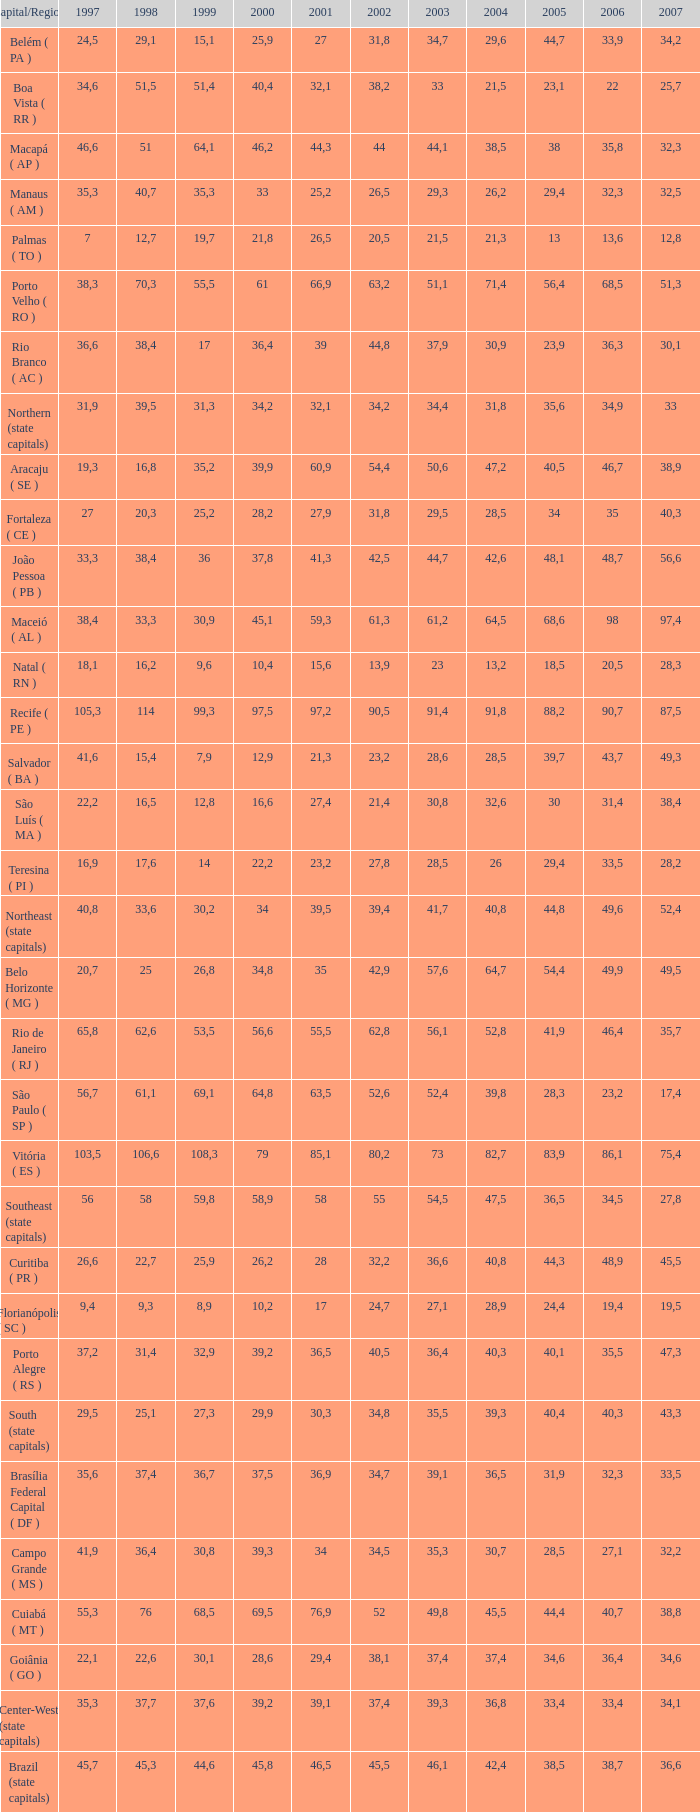Could you parse the entire table as a dict? {'header': ['Capital/Region', '1997', '1998', '1999', '2000', '2001', '2002', '2003', '2004', '2005', '2006', '2007'], 'rows': [['Belém ( PA )', '24,5', '29,1', '15,1', '25,9', '27', '31,8', '34,7', '29,6', '44,7', '33,9', '34,2'], ['Boa Vista ( RR )', '34,6', '51,5', '51,4', '40,4', '32,1', '38,2', '33', '21,5', '23,1', '22', '25,7'], ['Macapá ( AP )', '46,6', '51', '64,1', '46,2', '44,3', '44', '44,1', '38,5', '38', '35,8', '32,3'], ['Manaus ( AM )', '35,3', '40,7', '35,3', '33', '25,2', '26,5', '29,3', '26,2', '29,4', '32,3', '32,5'], ['Palmas ( TO )', '7', '12,7', '19,7', '21,8', '26,5', '20,5', '21,5', '21,3', '13', '13,6', '12,8'], ['Porto Velho ( RO )', '38,3', '70,3', '55,5', '61', '66,9', '63,2', '51,1', '71,4', '56,4', '68,5', '51,3'], ['Rio Branco ( AC )', '36,6', '38,4', '17', '36,4', '39', '44,8', '37,9', '30,9', '23,9', '36,3', '30,1'], ['Northern (state capitals)', '31,9', '39,5', '31,3', '34,2', '32,1', '34,2', '34,4', '31,8', '35,6', '34,9', '33'], ['Aracaju ( SE )', '19,3', '16,8', '35,2', '39,9', '60,9', '54,4', '50,6', '47,2', '40,5', '46,7', '38,9'], ['Fortaleza ( CE )', '27', '20,3', '25,2', '28,2', '27,9', '31,8', '29,5', '28,5', '34', '35', '40,3'], ['João Pessoa ( PB )', '33,3', '38,4', '36', '37,8', '41,3', '42,5', '44,7', '42,6', '48,1', '48,7', '56,6'], ['Maceió ( AL )', '38,4', '33,3', '30,9', '45,1', '59,3', '61,3', '61,2', '64,5', '68,6', '98', '97,4'], ['Natal ( RN )', '18,1', '16,2', '9,6', '10,4', '15,6', '13,9', '23', '13,2', '18,5', '20,5', '28,3'], ['Recife ( PE )', '105,3', '114', '99,3', '97,5', '97,2', '90,5', '91,4', '91,8', '88,2', '90,7', '87,5'], ['Salvador ( BA )', '41,6', '15,4', '7,9', '12,9', '21,3', '23,2', '28,6', '28,5', '39,7', '43,7', '49,3'], ['São Luís ( MA )', '22,2', '16,5', '12,8', '16,6', '27,4', '21,4', '30,8', '32,6', '30', '31,4', '38,4'], ['Teresina ( PI )', '16,9', '17,6', '14', '22,2', '23,2', '27,8', '28,5', '26', '29,4', '33,5', '28,2'], ['Northeast (state capitals)', '40,8', '33,6', '30,2', '34', '39,5', '39,4', '41,7', '40,8', '44,8', '49,6', '52,4'], ['Belo Horizonte ( MG )', '20,7', '25', '26,8', '34,8', '35', '42,9', '57,6', '64,7', '54,4', '49,9', '49,5'], ['Rio de Janeiro ( RJ )', '65,8', '62,6', '53,5', '56,6', '55,5', '62,8', '56,1', '52,8', '41,9', '46,4', '35,7'], ['São Paulo ( SP )', '56,7', '61,1', '69,1', '64,8', '63,5', '52,6', '52,4', '39,8', '28,3', '23,2', '17,4'], ['Vitória ( ES )', '103,5', '106,6', '108,3', '79', '85,1', '80,2', '73', '82,7', '83,9', '86,1', '75,4'], ['Southeast (state capitals)', '56', '58', '59,8', '58,9', '58', '55', '54,5', '47,5', '36,5', '34,5', '27,8'], ['Curitiba ( PR )', '26,6', '22,7', '25,9', '26,2', '28', '32,2', '36,6', '40,8', '44,3', '48,9', '45,5'], ['Florianópolis ( SC )', '9,4', '9,3', '8,9', '10,2', '17', '24,7', '27,1', '28,9', '24,4', '19,4', '19,5'], ['Porto Alegre ( RS )', '37,2', '31,4', '32,9', '39,2', '36,5', '40,5', '36,4', '40,3', '40,1', '35,5', '47,3'], ['South (state capitals)', '29,5', '25,1', '27,3', '29,9', '30,3', '34,8', '35,5', '39,3', '40,4', '40,3', '43,3'], ['Brasília Federal Capital ( DF )', '35,6', '37,4', '36,7', '37,5', '36,9', '34,7', '39,1', '36,5', '31,9', '32,3', '33,5'], ['Campo Grande ( MS )', '41,9', '36,4', '30,8', '39,3', '34', '34,5', '35,3', '30,7', '28,5', '27,1', '32,2'], ['Cuiabá ( MT )', '55,3', '76', '68,5', '69,5', '76,9', '52', '49,8', '45,5', '44,4', '40,7', '38,8'], ['Goiânia ( GO )', '22,1', '22,6', '30,1', '28,6', '29,4', '38,1', '37,4', '37,4', '34,6', '36,4', '34,6'], ['Center-West (state capitals)', '35,3', '37,7', '37,6', '39,2', '39,1', '37,4', '39,3', '36,8', '33,4', '33,4', '34,1'], ['Brazil (state capitals)', '45,7', '45,3', '44,6', '45,8', '46,5', '45,5', '46,1', '42,4', '38,5', '38,7', '36,6']]} How many 2007's have a 2000 greater than 56,6, 23,2 as 2006, and a 1998 greater than 61,1? None. 